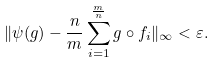Convert formula to latex. <formula><loc_0><loc_0><loc_500><loc_500>\| \psi ( g ) - \frac { n } { m } \sum _ { i = 1 } ^ { \frac { m } { n } } g \circ f _ { i } \| _ { \infty } < \varepsilon .</formula> 